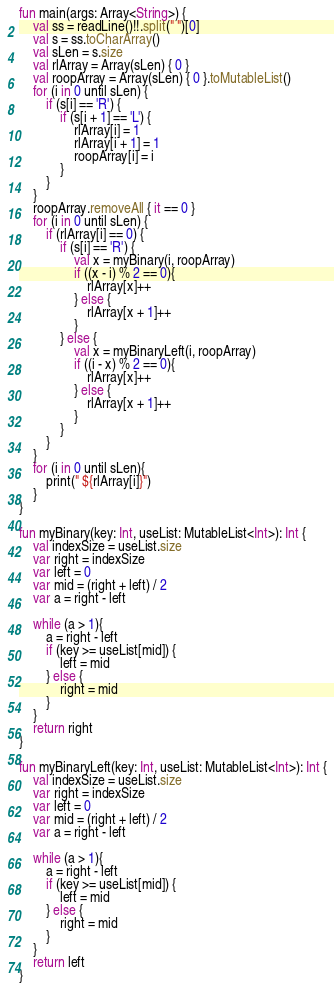Convert code to text. <code><loc_0><loc_0><loc_500><loc_500><_Kotlin_>fun main(args: Array<String>) {
    val ss = readLine()!!.split(" ")[0]
    val s = ss.toCharArray()
    val sLen = s.size
    val rlArray = Array(sLen) { 0 }
    val roopArray = Array(sLen) { 0 }.toMutableList()
    for (i in 0 until sLen) {
        if (s[i] == 'R') {
            if (s[i + 1] == 'L') {
                rlArray[i] = 1
                rlArray[i + 1] = 1
                roopArray[i] = i
            }
        }
    }
    roopArray.removeAll { it == 0 }
    for (i in 0 until sLen) {
        if (rlArray[i] == 0) {
            if (s[i] == 'R') {
                val x = myBinary(i, roopArray)
                if ((x - i) % 2 == 0){
                    rlArray[x]++
                } else {
                    rlArray[x + 1]++
                }
            } else {
                val x = myBinaryLeft(i, roopArray)
                if ((i - x) % 2 == 0){
                    rlArray[x]++
                } else {
                    rlArray[x + 1]++
                }
            }
        }
    }
    for (i in 0 until sLen){
        print(" ${rlArray[i]}")
    }
}

fun myBinary(key: Int, useList: MutableList<Int>): Int {
    val indexSize = useList.size
    var right = indexSize
    var left = 0
    var mid = (right + left) / 2
    var a = right - left

    while (a > 1){
        a = right - left
        if (key >= useList[mid]) {
            left = mid
        } else {
            right = mid
        }
    }
    return right
}

fun myBinaryLeft(key: Int, useList: MutableList<Int>): Int {
    val indexSize = useList.size
    var right = indexSize
    var left = 0
    var mid = (right + left) / 2
    var a = right - left

    while (a > 1){
        a = right - left
        if (key >= useList[mid]) {
            left = mid
        } else {
            right = mid
        }
    }
    return left
}</code> 